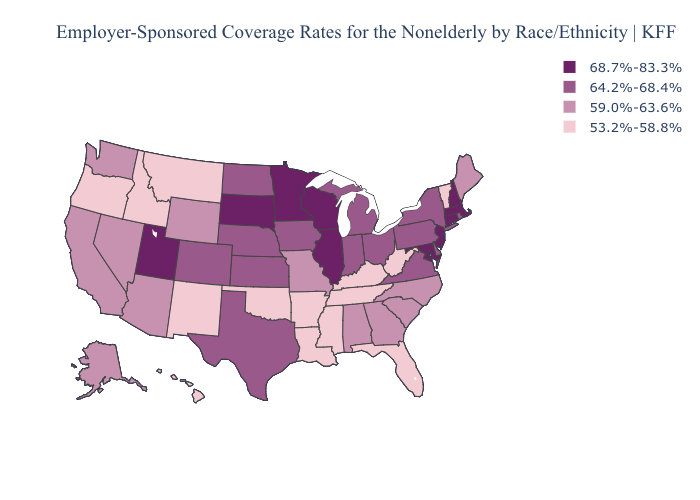Which states have the highest value in the USA?
Write a very short answer. Connecticut, Illinois, Maryland, Massachusetts, Minnesota, New Hampshire, New Jersey, South Dakota, Utah, Wisconsin. Which states have the lowest value in the Northeast?
Short answer required. Vermont. Does Alaska have the same value as North Dakota?
Answer briefly. No. What is the value of Texas?
Short answer required. 64.2%-68.4%. Which states have the lowest value in the West?
Keep it brief. Hawaii, Idaho, Montana, New Mexico, Oregon. Name the states that have a value in the range 53.2%-58.8%?
Quick response, please. Arkansas, Florida, Hawaii, Idaho, Kentucky, Louisiana, Mississippi, Montana, New Mexico, Oklahoma, Oregon, Tennessee, Vermont, West Virginia. Does Alabama have a higher value than Florida?
Concise answer only. Yes. Does Washington have the same value as Wyoming?
Be succinct. Yes. Which states hav the highest value in the MidWest?
Be succinct. Illinois, Minnesota, South Dakota, Wisconsin. Which states have the lowest value in the USA?
Be succinct. Arkansas, Florida, Hawaii, Idaho, Kentucky, Louisiana, Mississippi, Montana, New Mexico, Oklahoma, Oregon, Tennessee, Vermont, West Virginia. Name the states that have a value in the range 59.0%-63.6%?
Give a very brief answer. Alabama, Alaska, Arizona, California, Georgia, Maine, Missouri, Nevada, North Carolina, South Carolina, Washington, Wyoming. What is the value of Missouri?
Quick response, please. 59.0%-63.6%. What is the value of Louisiana?
Quick response, please. 53.2%-58.8%. Name the states that have a value in the range 59.0%-63.6%?
Keep it brief. Alabama, Alaska, Arizona, California, Georgia, Maine, Missouri, Nevada, North Carolina, South Carolina, Washington, Wyoming. Does South Dakota have the lowest value in the MidWest?
Concise answer only. No. 